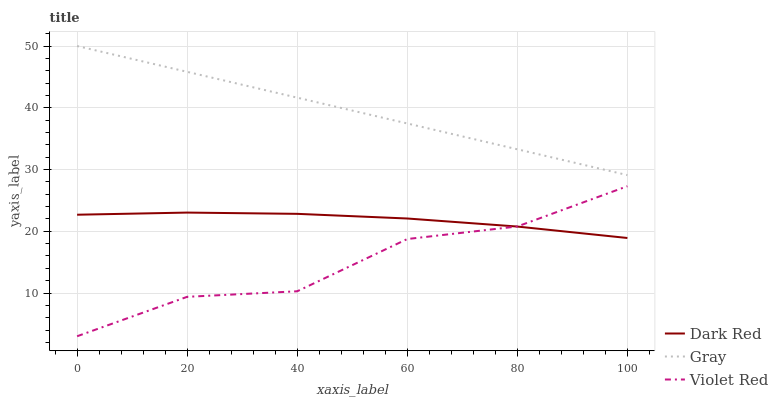Does Violet Red have the minimum area under the curve?
Answer yes or no. Yes. Does Gray have the maximum area under the curve?
Answer yes or no. Yes. Does Gray have the minimum area under the curve?
Answer yes or no. No. Does Violet Red have the maximum area under the curve?
Answer yes or no. No. Is Gray the smoothest?
Answer yes or no. Yes. Is Violet Red the roughest?
Answer yes or no. Yes. Is Violet Red the smoothest?
Answer yes or no. No. Is Gray the roughest?
Answer yes or no. No. Does Violet Red have the lowest value?
Answer yes or no. Yes. Does Gray have the lowest value?
Answer yes or no. No. Does Gray have the highest value?
Answer yes or no. Yes. Does Violet Red have the highest value?
Answer yes or no. No. Is Violet Red less than Gray?
Answer yes or no. Yes. Is Gray greater than Dark Red?
Answer yes or no. Yes. Does Violet Red intersect Dark Red?
Answer yes or no. Yes. Is Violet Red less than Dark Red?
Answer yes or no. No. Is Violet Red greater than Dark Red?
Answer yes or no. No. Does Violet Red intersect Gray?
Answer yes or no. No. 